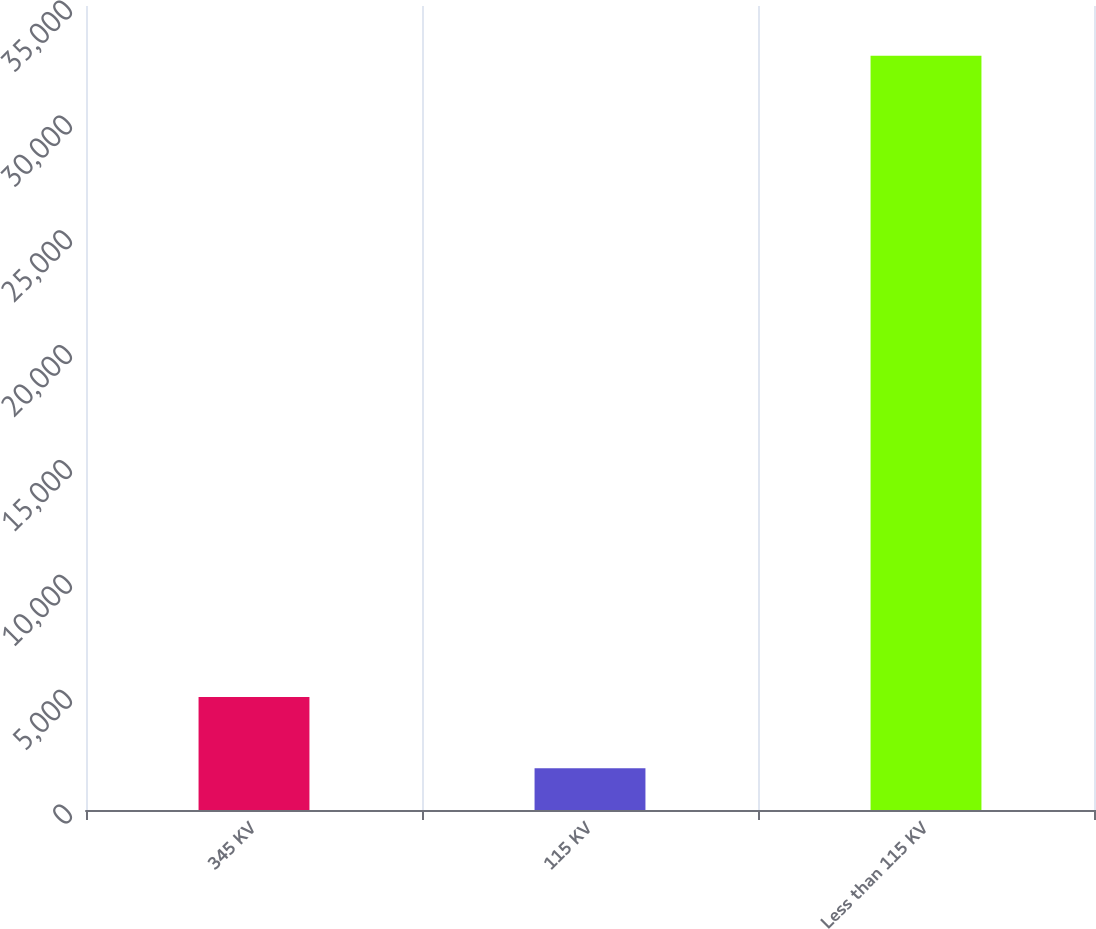<chart> <loc_0><loc_0><loc_500><loc_500><bar_chart><fcel>345 KV<fcel>115 KV<fcel>Less than 115 KV<nl><fcel>4918.4<fcel>1817<fcel>32831<nl></chart> 